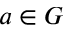Convert formula to latex. <formula><loc_0><loc_0><loc_500><loc_500>a \in G</formula> 